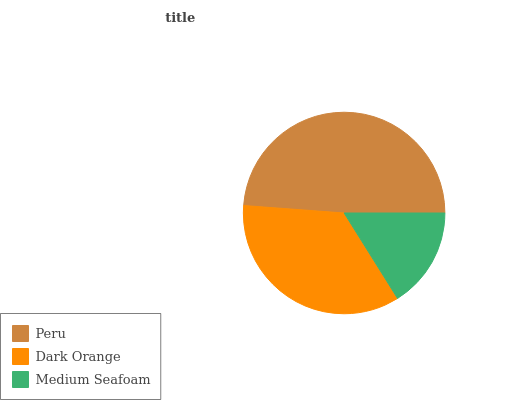Is Medium Seafoam the minimum?
Answer yes or no. Yes. Is Peru the maximum?
Answer yes or no. Yes. Is Dark Orange the minimum?
Answer yes or no. No. Is Dark Orange the maximum?
Answer yes or no. No. Is Peru greater than Dark Orange?
Answer yes or no. Yes. Is Dark Orange less than Peru?
Answer yes or no. Yes. Is Dark Orange greater than Peru?
Answer yes or no. No. Is Peru less than Dark Orange?
Answer yes or no. No. Is Dark Orange the high median?
Answer yes or no. Yes. Is Dark Orange the low median?
Answer yes or no. Yes. Is Peru the high median?
Answer yes or no. No. Is Peru the low median?
Answer yes or no. No. 